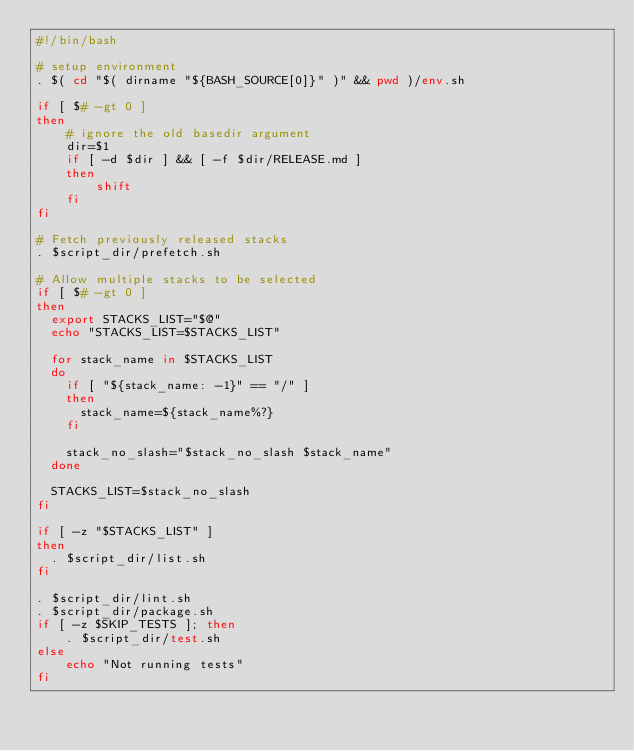<code> <loc_0><loc_0><loc_500><loc_500><_Bash_>#!/bin/bash

# setup environment
. $( cd "$( dirname "${BASH_SOURCE[0]}" )" && pwd )/env.sh

if [ $# -gt 0 ]
then
    # ignore the old basedir argument
    dir=$1
    if [ -d $dir ] && [ -f $dir/RELEASE.md ]
    then
        shift
    fi
fi

# Fetch previously released stacks
. $script_dir/prefetch.sh

# Allow multiple stacks to be selected
if [ $# -gt 0 ]
then
  export STACKS_LIST="$@"
  echo "STACKS_LIST=$STACKS_LIST"

  for stack_name in $STACKS_LIST
  do
    if [ "${stack_name: -1}" == "/" ]
    then
      stack_name=${stack_name%?}
    fi
     
    stack_no_slash="$stack_no_slash $stack_name"
  done

  STACKS_LIST=$stack_no_slash
fi

if [ -z "$STACKS_LIST" ]
then
  . $script_dir/list.sh
fi

. $script_dir/lint.sh
. $script_dir/package.sh
if [ -z $SKIP_TESTS ]; then
    . $script_dir/test.sh
else
    echo "Not running tests"
fi
</code> 